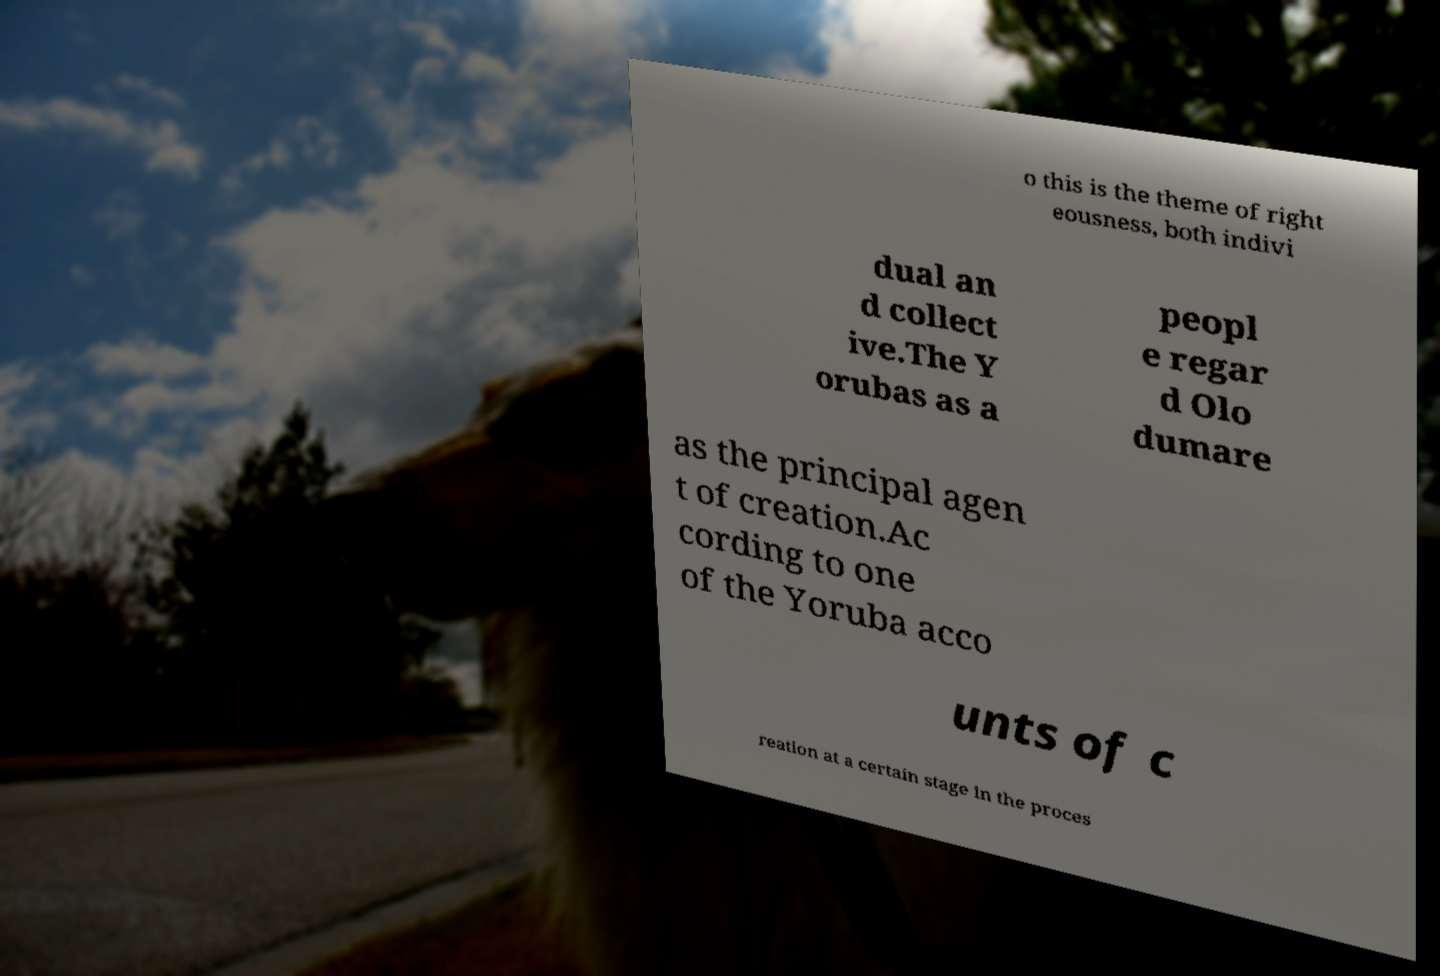For documentation purposes, I need the text within this image transcribed. Could you provide that? o this is the theme of right eousness, both indivi dual an d collect ive.The Y orubas as a peopl e regar d Olo dumare as the principal agen t of creation.Ac cording to one of the Yoruba acco unts of c reation at a certain stage in the proces 